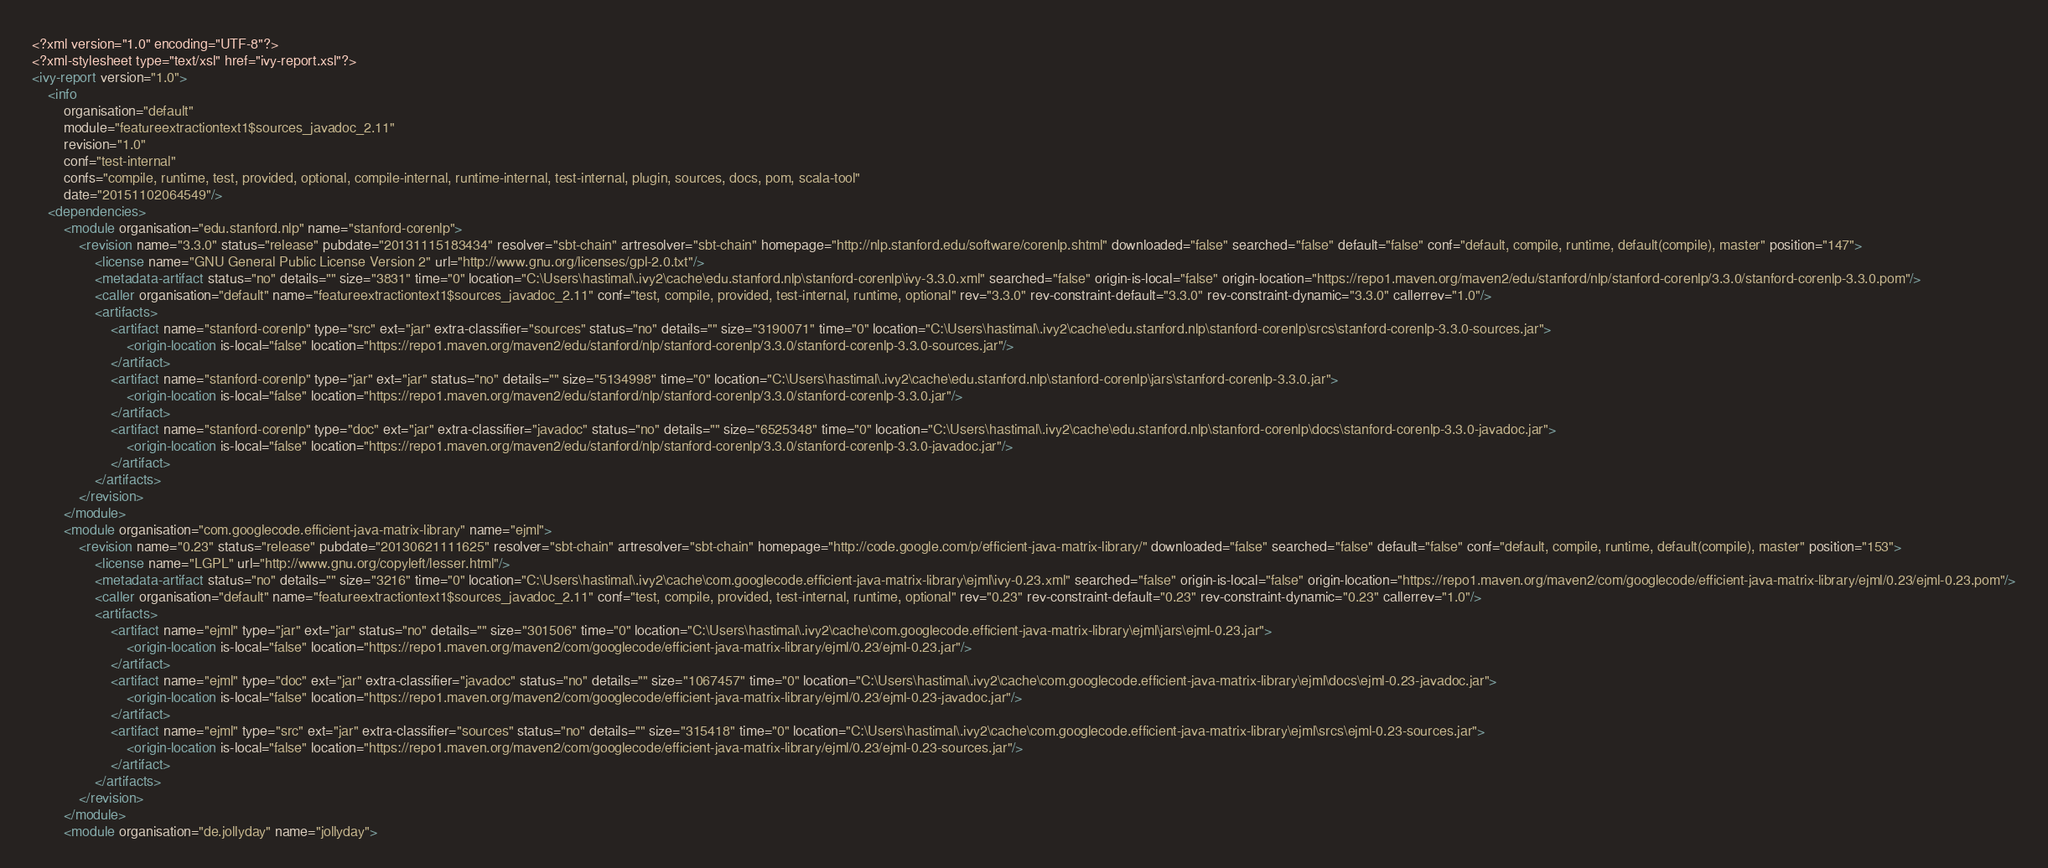Convert code to text. <code><loc_0><loc_0><loc_500><loc_500><_XML_><?xml version="1.0" encoding="UTF-8"?>
<?xml-stylesheet type="text/xsl" href="ivy-report.xsl"?>
<ivy-report version="1.0">
	<info
		organisation="default"
		module="featureextractiontext1$sources_javadoc_2.11"
		revision="1.0"
		conf="test-internal"
		confs="compile, runtime, test, provided, optional, compile-internal, runtime-internal, test-internal, plugin, sources, docs, pom, scala-tool"
		date="20151102064549"/>
	<dependencies>
		<module organisation="edu.stanford.nlp" name="stanford-corenlp">
			<revision name="3.3.0" status="release" pubdate="20131115183434" resolver="sbt-chain" artresolver="sbt-chain" homepage="http://nlp.stanford.edu/software/corenlp.shtml" downloaded="false" searched="false" default="false" conf="default, compile, runtime, default(compile), master" position="147">
				<license name="GNU General Public License Version 2" url="http://www.gnu.org/licenses/gpl-2.0.txt"/>
				<metadata-artifact status="no" details="" size="3831" time="0" location="C:\Users\hastimal\.ivy2\cache\edu.stanford.nlp\stanford-corenlp\ivy-3.3.0.xml" searched="false" origin-is-local="false" origin-location="https://repo1.maven.org/maven2/edu/stanford/nlp/stanford-corenlp/3.3.0/stanford-corenlp-3.3.0.pom"/>
				<caller organisation="default" name="featureextractiontext1$sources_javadoc_2.11" conf="test, compile, provided, test-internal, runtime, optional" rev="3.3.0" rev-constraint-default="3.3.0" rev-constraint-dynamic="3.3.0" callerrev="1.0"/>
				<artifacts>
					<artifact name="stanford-corenlp" type="src" ext="jar" extra-classifier="sources" status="no" details="" size="3190071" time="0" location="C:\Users\hastimal\.ivy2\cache\edu.stanford.nlp\stanford-corenlp\srcs\stanford-corenlp-3.3.0-sources.jar">
						<origin-location is-local="false" location="https://repo1.maven.org/maven2/edu/stanford/nlp/stanford-corenlp/3.3.0/stanford-corenlp-3.3.0-sources.jar"/>
					</artifact>
					<artifact name="stanford-corenlp" type="jar" ext="jar" status="no" details="" size="5134998" time="0" location="C:\Users\hastimal\.ivy2\cache\edu.stanford.nlp\stanford-corenlp\jars\stanford-corenlp-3.3.0.jar">
						<origin-location is-local="false" location="https://repo1.maven.org/maven2/edu/stanford/nlp/stanford-corenlp/3.3.0/stanford-corenlp-3.3.0.jar"/>
					</artifact>
					<artifact name="stanford-corenlp" type="doc" ext="jar" extra-classifier="javadoc" status="no" details="" size="6525348" time="0" location="C:\Users\hastimal\.ivy2\cache\edu.stanford.nlp\stanford-corenlp\docs\stanford-corenlp-3.3.0-javadoc.jar">
						<origin-location is-local="false" location="https://repo1.maven.org/maven2/edu/stanford/nlp/stanford-corenlp/3.3.0/stanford-corenlp-3.3.0-javadoc.jar"/>
					</artifact>
				</artifacts>
			</revision>
		</module>
		<module organisation="com.googlecode.efficient-java-matrix-library" name="ejml">
			<revision name="0.23" status="release" pubdate="20130621111625" resolver="sbt-chain" artresolver="sbt-chain" homepage="http://code.google.com/p/efficient-java-matrix-library/" downloaded="false" searched="false" default="false" conf="default, compile, runtime, default(compile), master" position="153">
				<license name="LGPL" url="http://www.gnu.org/copyleft/lesser.html"/>
				<metadata-artifact status="no" details="" size="3216" time="0" location="C:\Users\hastimal\.ivy2\cache\com.googlecode.efficient-java-matrix-library\ejml\ivy-0.23.xml" searched="false" origin-is-local="false" origin-location="https://repo1.maven.org/maven2/com/googlecode/efficient-java-matrix-library/ejml/0.23/ejml-0.23.pom"/>
				<caller organisation="default" name="featureextractiontext1$sources_javadoc_2.11" conf="test, compile, provided, test-internal, runtime, optional" rev="0.23" rev-constraint-default="0.23" rev-constraint-dynamic="0.23" callerrev="1.0"/>
				<artifacts>
					<artifact name="ejml" type="jar" ext="jar" status="no" details="" size="301506" time="0" location="C:\Users\hastimal\.ivy2\cache\com.googlecode.efficient-java-matrix-library\ejml\jars\ejml-0.23.jar">
						<origin-location is-local="false" location="https://repo1.maven.org/maven2/com/googlecode/efficient-java-matrix-library/ejml/0.23/ejml-0.23.jar"/>
					</artifact>
					<artifact name="ejml" type="doc" ext="jar" extra-classifier="javadoc" status="no" details="" size="1067457" time="0" location="C:\Users\hastimal\.ivy2\cache\com.googlecode.efficient-java-matrix-library\ejml\docs\ejml-0.23-javadoc.jar">
						<origin-location is-local="false" location="https://repo1.maven.org/maven2/com/googlecode/efficient-java-matrix-library/ejml/0.23/ejml-0.23-javadoc.jar"/>
					</artifact>
					<artifact name="ejml" type="src" ext="jar" extra-classifier="sources" status="no" details="" size="315418" time="0" location="C:\Users\hastimal\.ivy2\cache\com.googlecode.efficient-java-matrix-library\ejml\srcs\ejml-0.23-sources.jar">
						<origin-location is-local="false" location="https://repo1.maven.org/maven2/com/googlecode/efficient-java-matrix-library/ejml/0.23/ejml-0.23-sources.jar"/>
					</artifact>
				</artifacts>
			</revision>
		</module>
		<module organisation="de.jollyday" name="jollyday"></code> 